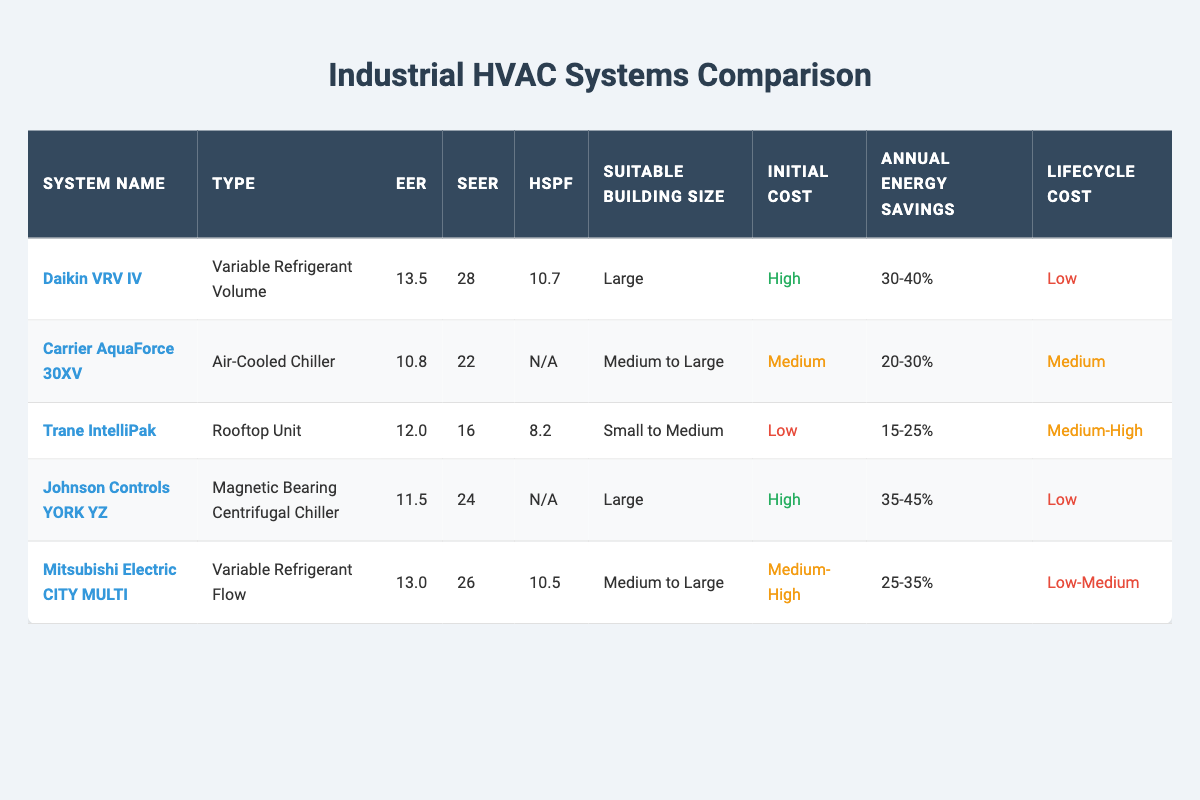What is the energy efficiency ratio (EER) of the Daikin VRV IV system? The EER value of the Daikin VRV IV system is directly listed in the table as 13.5.
Answer: 13.5 Which HVAC system has the highest seasonal energy efficiency ratio (SEER)? The table shows that the Daikin VRV IV has the highest SEER at 28, compared to other systems listed.
Answer: Daikin VRV IV Is the Johnson Controls YORK YZ suitable for small buildings? The table indicates that the Johnson Controls YORK YZ system is suitable for large buildings, not small ones.
Answer: No What is the average annual energy savings for all systems listed? To find the average, we convert each system's savings range into a single value: Daikin VRV IV (35%), Carrier AquaForce 30XV (25%), Trane IntelliPak (20%), Johnson Controls YORK YZ (40%), and Mitsubishi Electric CITY MULTI (30%). The total is 35 + 25 + 20 + 40 + 30 = 150, and the average is 150/5 = 30%.
Answer: 30% How many HVAC systems have a lifecycle cost categorized as low? From the table, Daikin VRV IV and Johnson Controls YORK YZ are both marked with a lifecycle cost of low, totaling 2 systems.
Answer: 2 What is the difference in energy efficiency ratio (EER) between the highest and lowest rated systems? The highest EER is Daikin VRV IV with 13.5, while the lowest is Carrier AquaForce 30XV with 10.8. The difference is calculated as 13.5 - 10.8 = 2.7.
Answer: 2.7 Does any system lack a heating seasonal performance factor (HSPF)? The table shows that both Carrier AquaForce 30XV and Johnson Controls YORK YZ have 'N/A' for their HSPF, indicating that they lack this value.
Answer: Yes Which system is most cost-effective considering initial costs and lifetime savings? By evaluating both initial costs and projected savings, Daikin VRV IV has high initial costs but low lifecycle costs, and high annual energy savings of 30-40%. The decision would depend on specific building size and energy cost.
Answer: It's complex; depends on specifics 